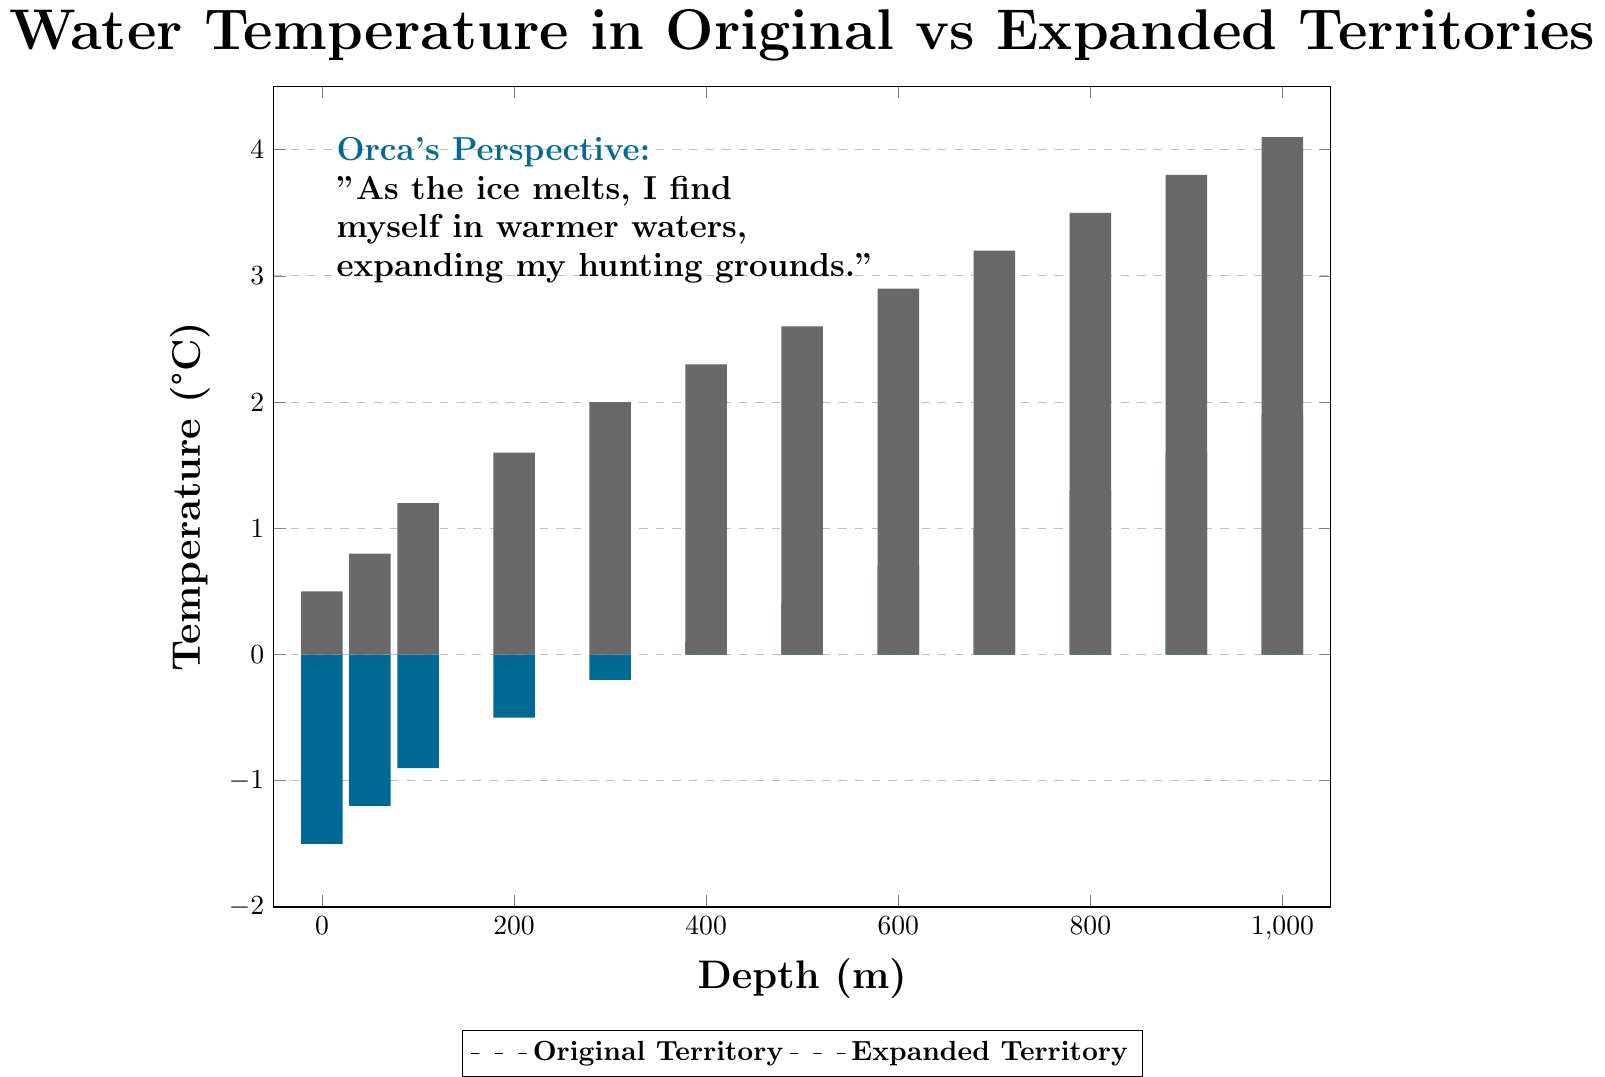Which depth shows the greatest temperature difference between the original and expanded territories? To find the greatest temperature difference, calculate the difference between the expanded and original temperature for each depth. The greatest difference is at depth 1000m (4.1°C - 1.9°C = 2.2°C).
Answer: 1000m At which depth are the temperatures in the original and expanded territories equal? By inspecting the bar chart, there are no depths where the temperatures in the original and expanded territories are equal, as the expanded territories are consistently warmer.
Answer: None How does the temperature difference between the original and expanded territories change as depth increases? The temperature difference is the original territory temperature subtracted from the expanded territory temperature. It consistently increases as depth increases, starting from 2.0°C at 0m to 2.2°C at 1000m.
Answer: Increases Compare the temperature at 400m in the original territory to the temperature at 200m in the expanded territory. Which one is higher? By examining the heights of the bars, the temperature at 400m in the original territory (0.1°C) is lower than at 200m in the expanded territory (1.6°C).
Answer: 200m in the expanded territory What is the average temperature in the expanded territory at depths 0m, 500m, and 1000m? Add the temperatures at these depths in the expanded territory and divide by 3. (0.5 + 2.6 + 4.1)/3 = 7.2/3 = 2.4°C.
Answer: 2.4°C By how much does the temperature at 100m differ from the temperature at 300m in the expanded territory? Subtract the temperature at 100m from the temperature at 300m in the expanded territory: 2.0°C - 1.2°C = 0.8°C.
Answer: 0.8°C Does the temperature in the original territory ever reach above 2°C? Observing the original territory bars, the temperature never reaches above 2°C; it maxes out at 1.9°C.
Answer: No Which territory, original or expanded, has a greater constant rate of temperature change with increasing depth? Calculate the slope for each territory using changes in temperature values per 100m depth increments. The expanded territory has a consistent 0.3°C increase per 100m while the original territory increases vary but are generally slower, particularly at shallower depths.
Answer: Expanded What is the visual relationship between the heights of the bars representing the original and expanded territories at every measured depth? For each depth, the expanded territory's bar height is consistently higher than the corresponding original territory's bar height, indicating warmer temperatures.
Answer: Expanded territory bars are higher 